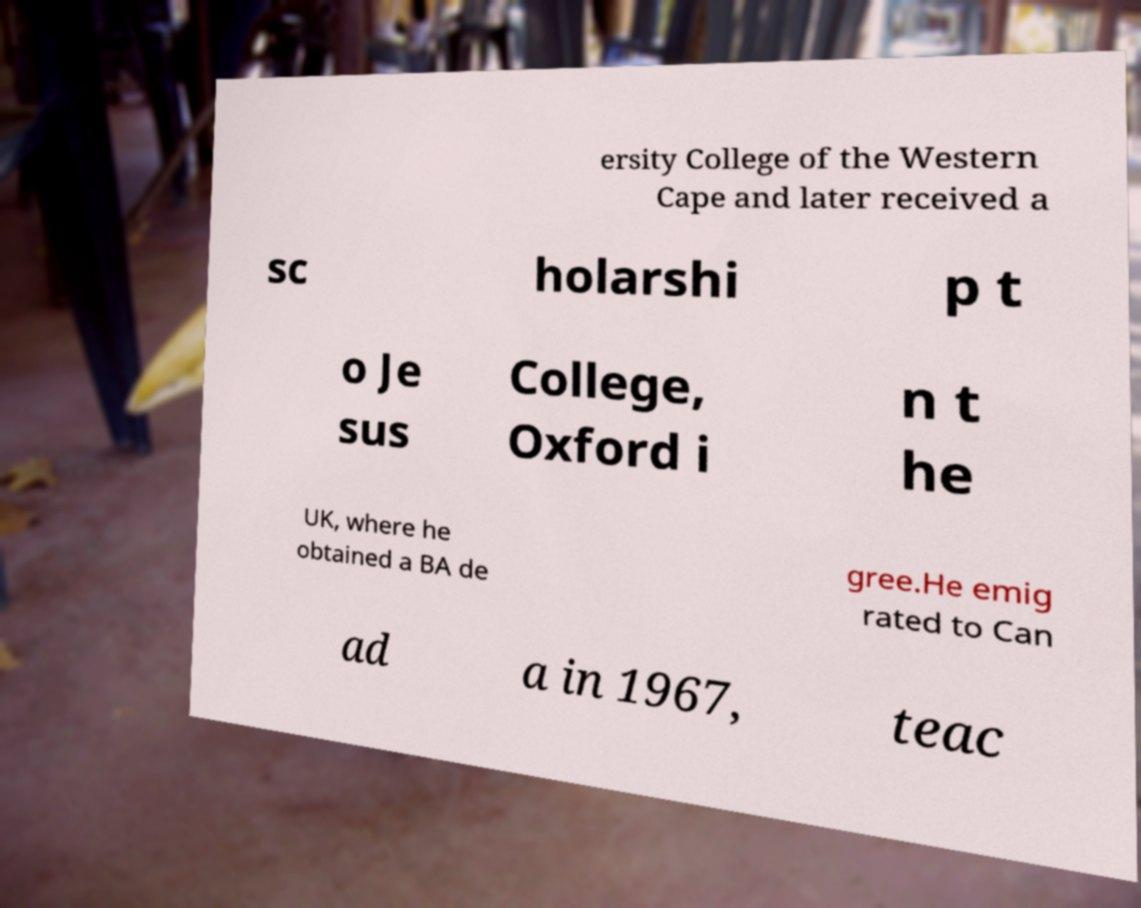Please identify and transcribe the text found in this image. ersity College of the Western Cape and later received a sc holarshi p t o Je sus College, Oxford i n t he UK, where he obtained a BA de gree.He emig rated to Can ad a in 1967, teac 